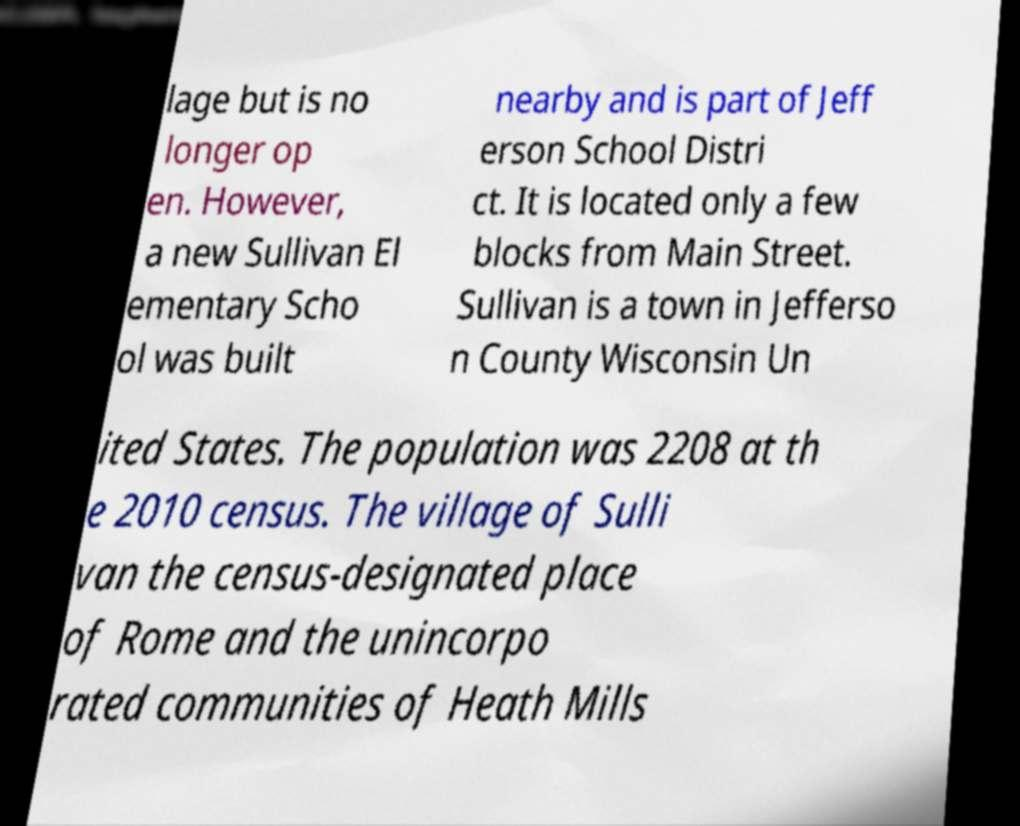I need the written content from this picture converted into text. Can you do that? lage but is no longer op en. However, a new Sullivan El ementary Scho ol was built nearby and is part of Jeff erson School Distri ct. It is located only a few blocks from Main Street. Sullivan is a town in Jefferso n County Wisconsin Un ited States. The population was 2208 at th e 2010 census. The village of Sulli van the census-designated place of Rome and the unincorpo rated communities of Heath Mills 